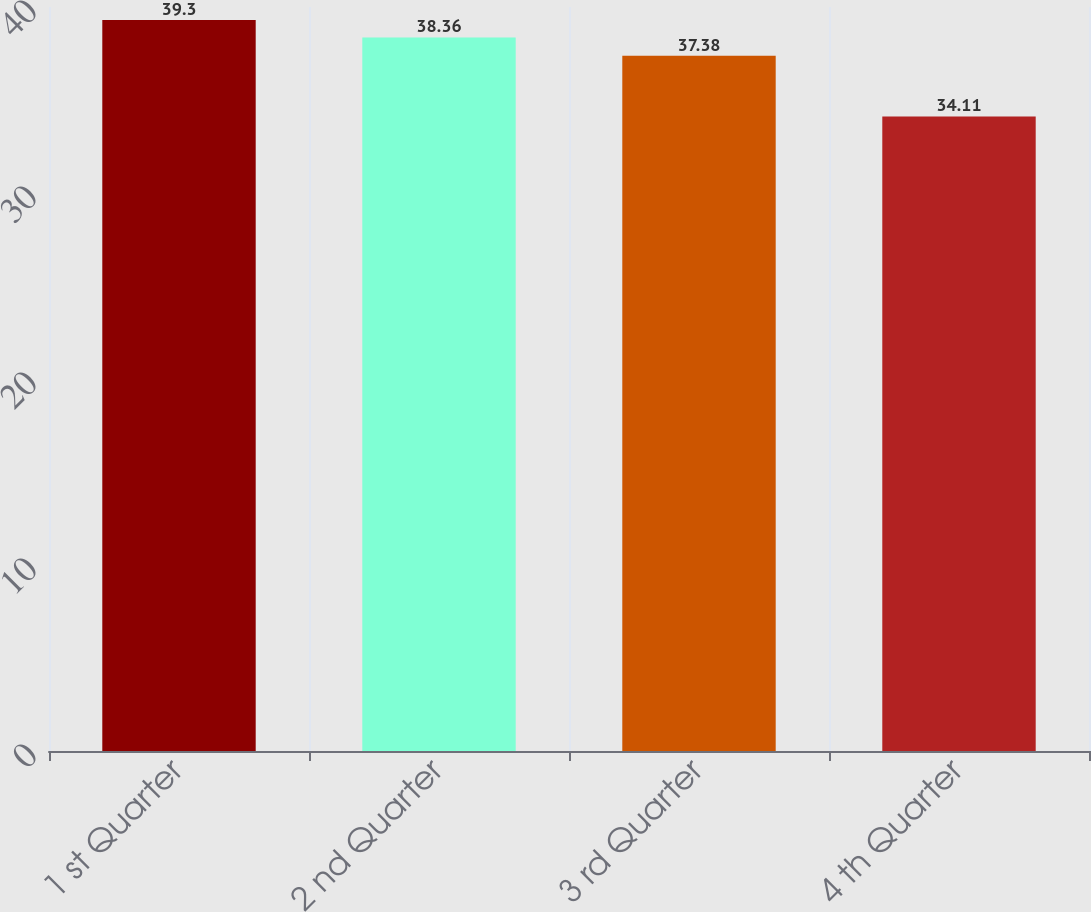<chart> <loc_0><loc_0><loc_500><loc_500><bar_chart><fcel>1 st Quarter<fcel>2 nd Quarter<fcel>3 rd Quarter<fcel>4 th Quarter<nl><fcel>39.3<fcel>38.36<fcel>37.38<fcel>34.11<nl></chart> 